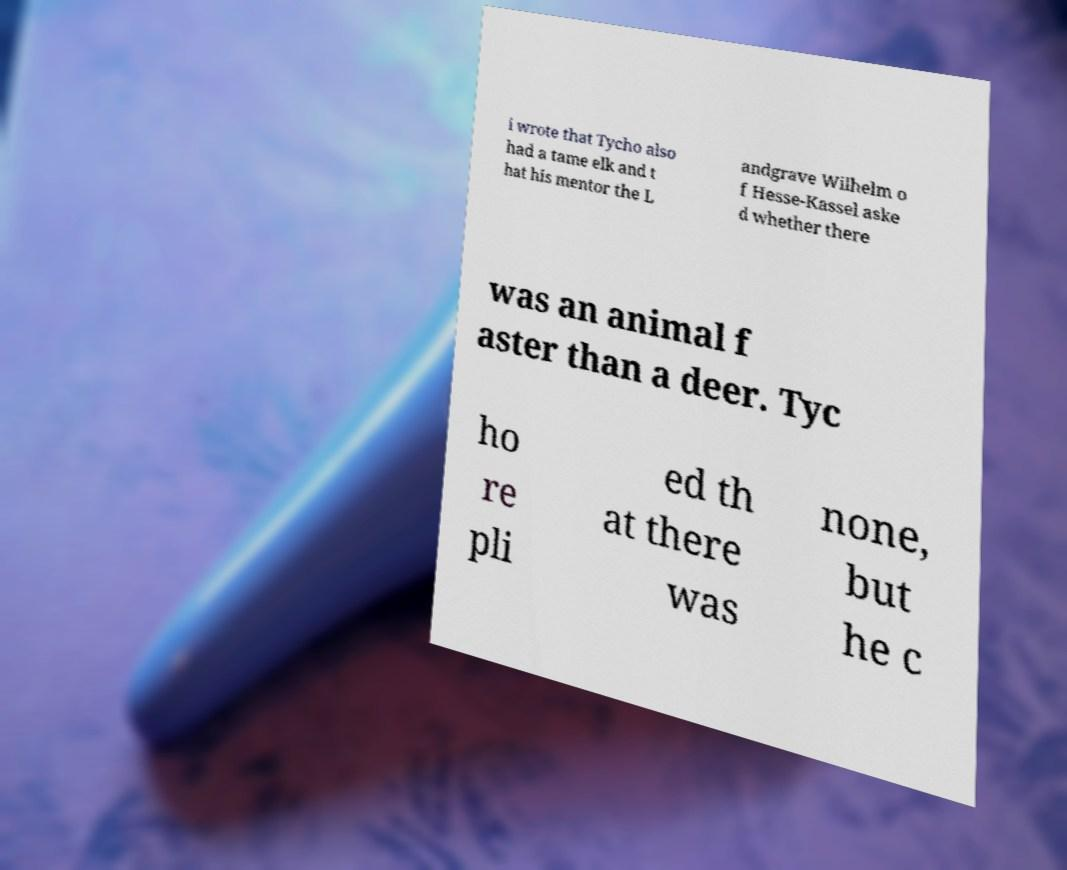There's text embedded in this image that I need extracted. Can you transcribe it verbatim? i wrote that Tycho also had a tame elk and t hat his mentor the L andgrave Wilhelm o f Hesse-Kassel aske d whether there was an animal f aster than a deer. Tyc ho re pli ed th at there was none, but he c 